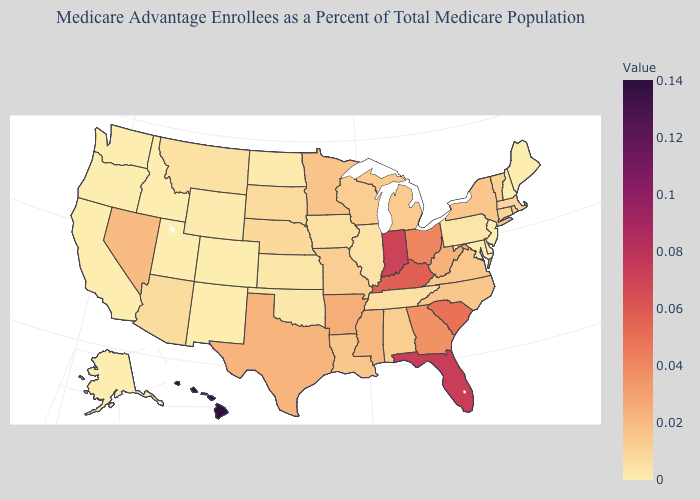Among the states that border Montana , which have the highest value?
Concise answer only. South Dakota. Among the states that border Indiana , which have the lowest value?
Short answer required. Illinois. Among the states that border New Mexico , does Colorado have the lowest value?
Quick response, please. Yes. Among the states that border Indiana , which have the highest value?
Concise answer only. Kentucky. 